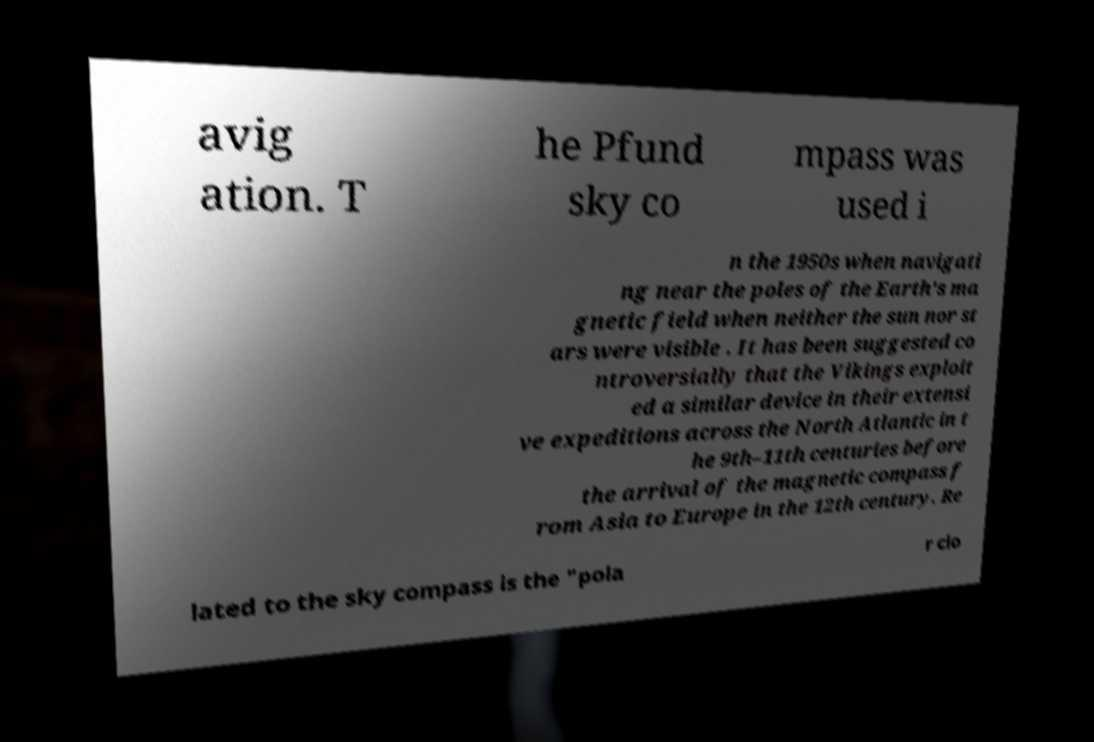For documentation purposes, I need the text within this image transcribed. Could you provide that? avig ation. T he Pfund sky co mpass was used i n the 1950s when navigati ng near the poles of the Earth's ma gnetic field when neither the sun nor st ars were visible . It has been suggested co ntroversially that the Vikings exploit ed a similar device in their extensi ve expeditions across the North Atlantic in t he 9th–11th centuries before the arrival of the magnetic compass f rom Asia to Europe in the 12th century. Re lated to the sky compass is the "pola r clo 